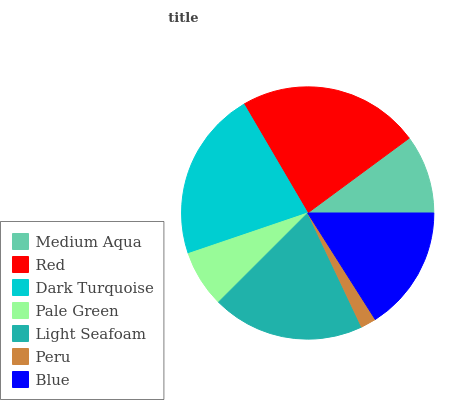Is Peru the minimum?
Answer yes or no. Yes. Is Red the maximum?
Answer yes or no. Yes. Is Dark Turquoise the minimum?
Answer yes or no. No. Is Dark Turquoise the maximum?
Answer yes or no. No. Is Red greater than Dark Turquoise?
Answer yes or no. Yes. Is Dark Turquoise less than Red?
Answer yes or no. Yes. Is Dark Turquoise greater than Red?
Answer yes or no. No. Is Red less than Dark Turquoise?
Answer yes or no. No. Is Blue the high median?
Answer yes or no. Yes. Is Blue the low median?
Answer yes or no. Yes. Is Dark Turquoise the high median?
Answer yes or no. No. Is Red the low median?
Answer yes or no. No. 